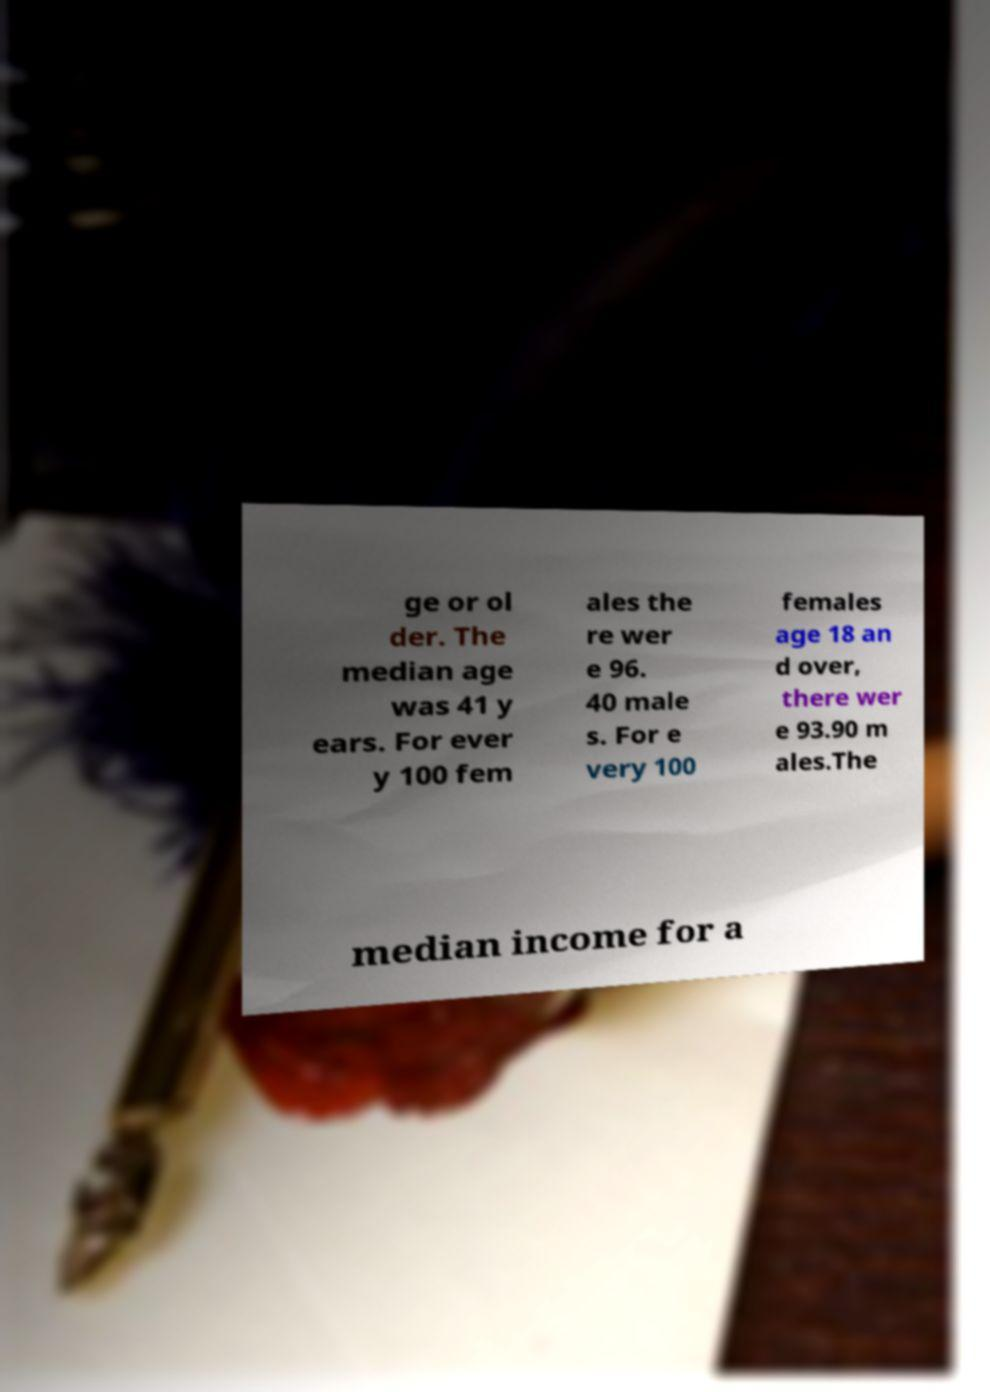Please identify and transcribe the text found in this image. ge or ol der. The median age was 41 y ears. For ever y 100 fem ales the re wer e 96. 40 male s. For e very 100 females age 18 an d over, there wer e 93.90 m ales.The median income for a 